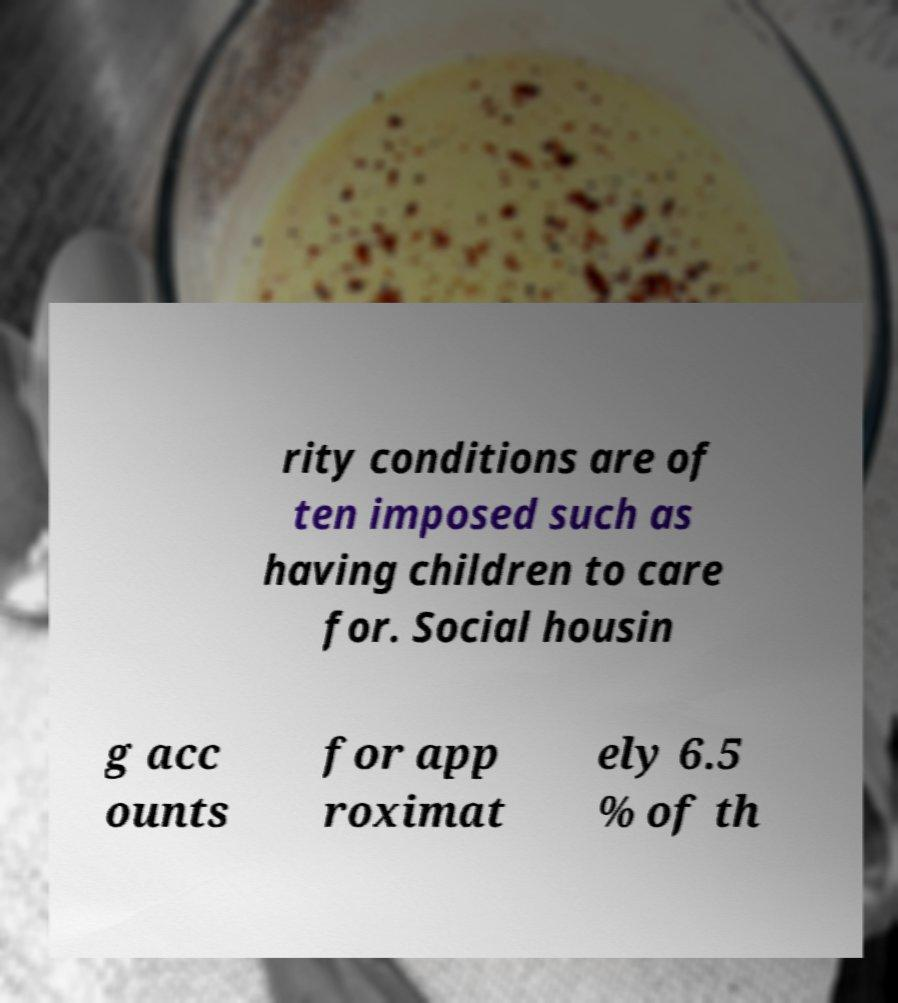Can you read and provide the text displayed in the image?This photo seems to have some interesting text. Can you extract and type it out for me? rity conditions are of ten imposed such as having children to care for. Social housin g acc ounts for app roximat ely 6.5 % of th 